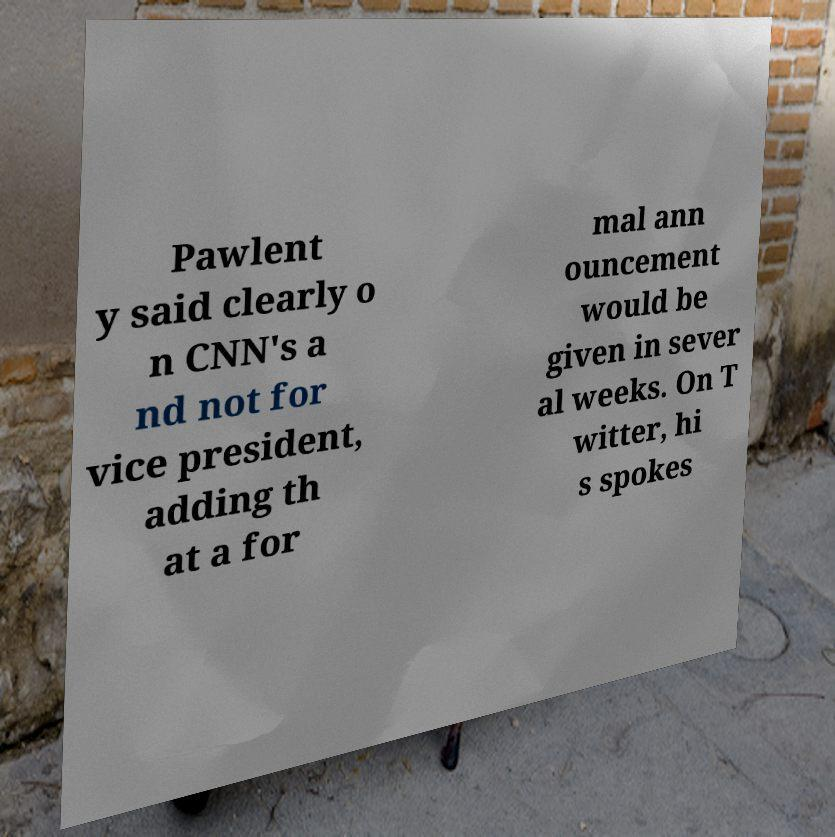Please identify and transcribe the text found in this image. Pawlent y said clearly o n CNN's a nd not for vice president, adding th at a for mal ann ouncement would be given in sever al weeks. On T witter, hi s spokes 